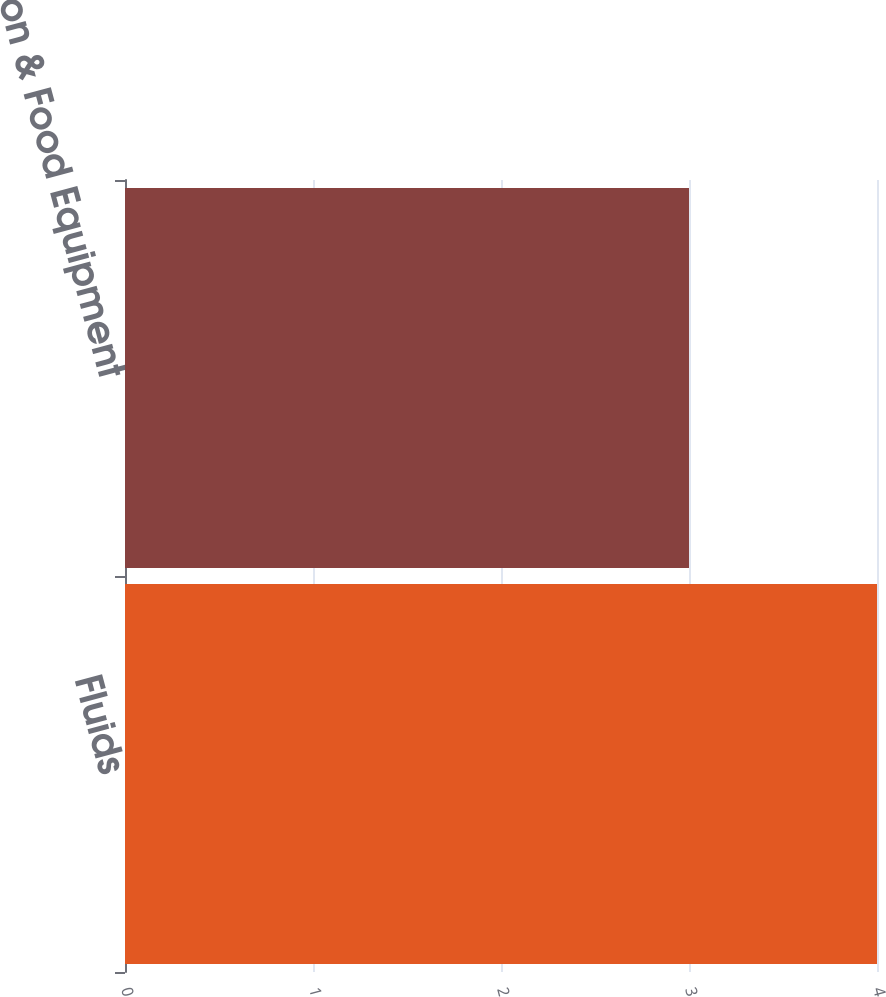<chart> <loc_0><loc_0><loc_500><loc_500><bar_chart><fcel>Fluids<fcel>Refrigeration & Food Equipment<nl><fcel>4<fcel>3<nl></chart> 